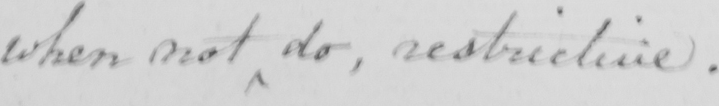Can you tell me what this handwritten text says? when not do , restrictive . 